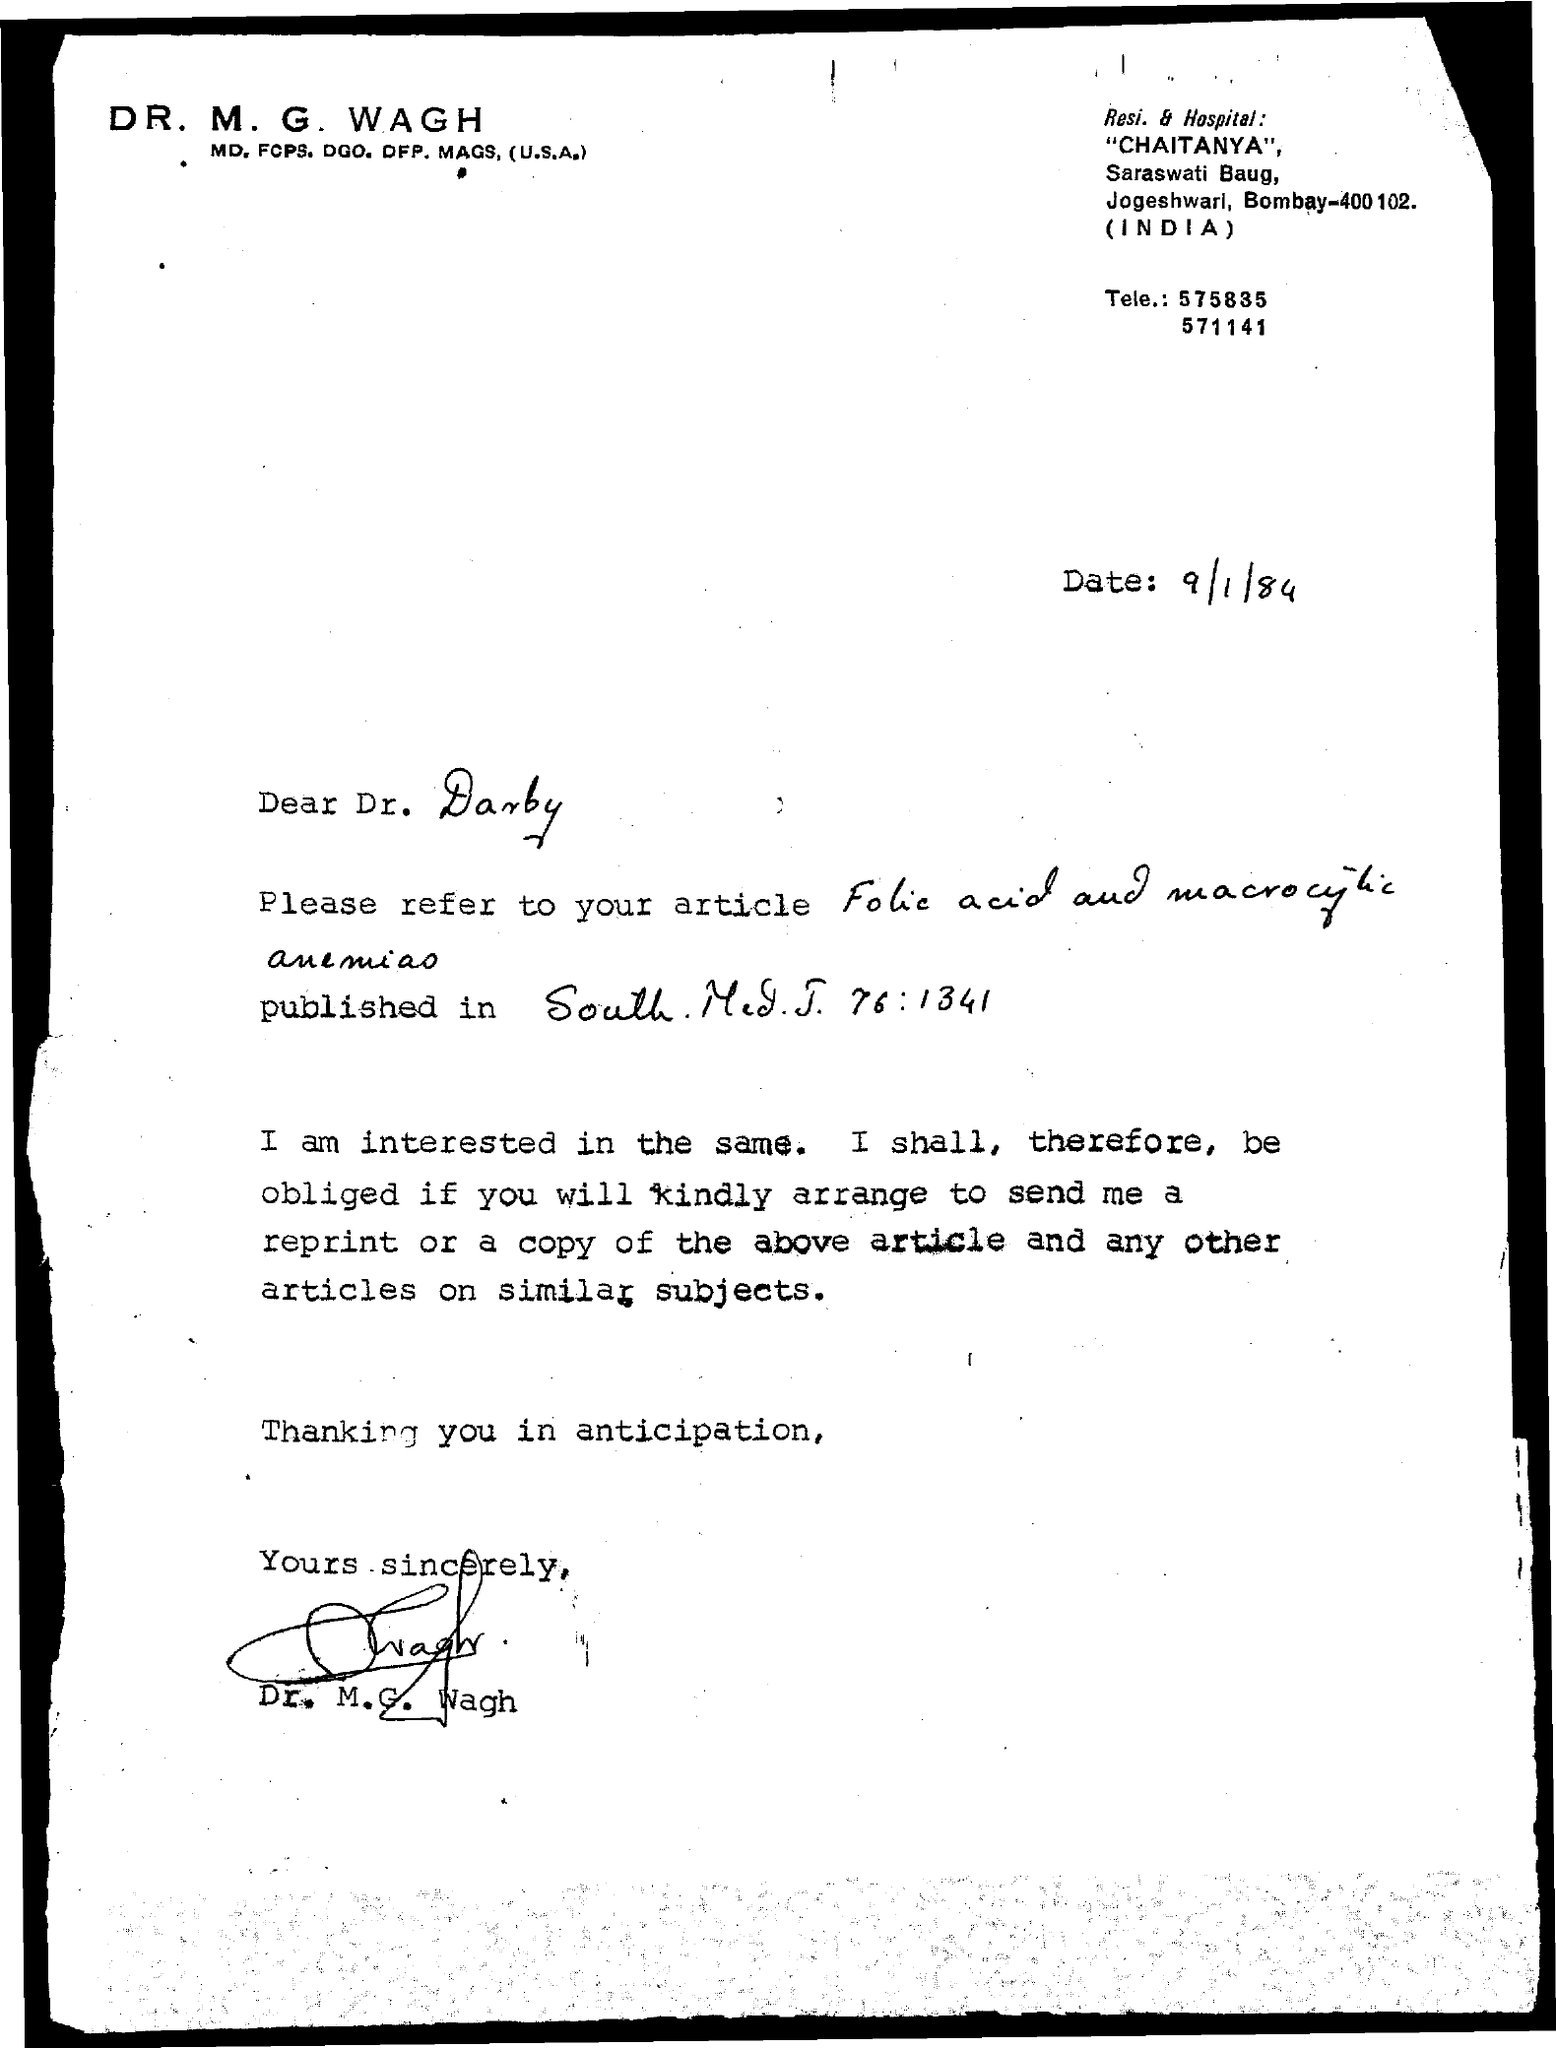Indicate a few pertinent items in this graphic. The signature of Dr. M.G. Wagh is signed at the bottom of the letter. The given letter mentions a date of September 1, 1984. 